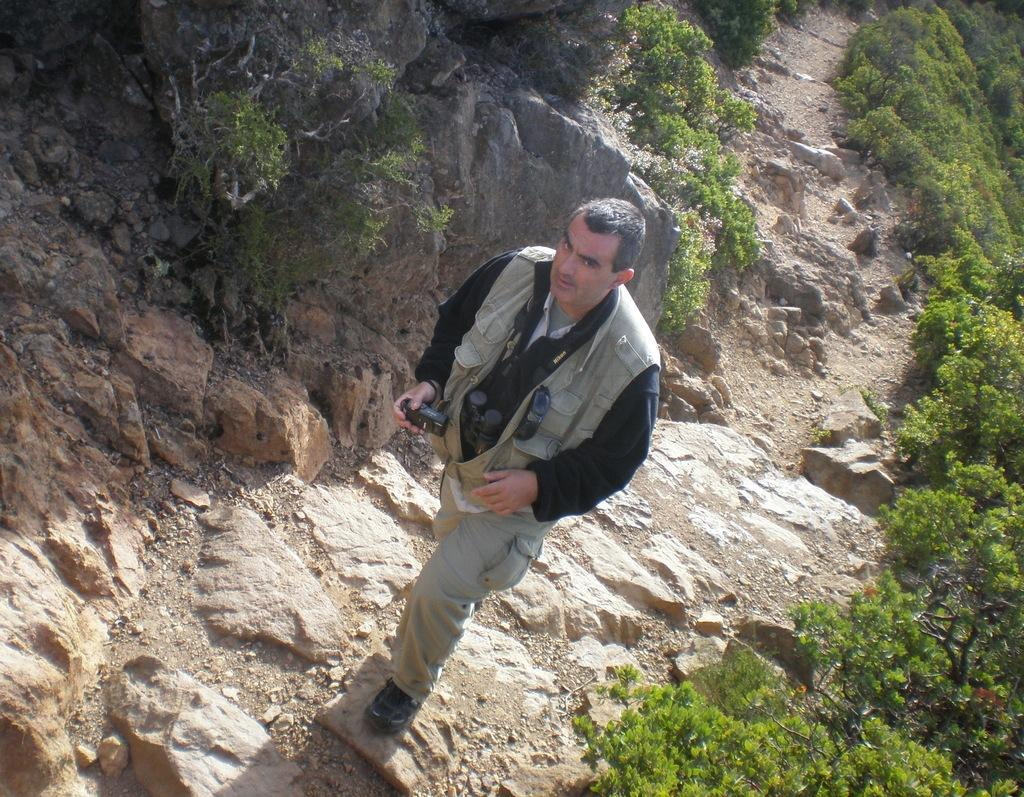Who is in the image? There is a person in the image, specifically a man. What is the man holding in the image? The man is holding a camera. What type of natural elements can be seen in the image? There are many plants and rocks in the image. What type of chalk can be seen on the plate in the image? There is no chalk or plate present in the image. What scent is associated with the plants in the image? The image does not provide information about the scent of the plants. 